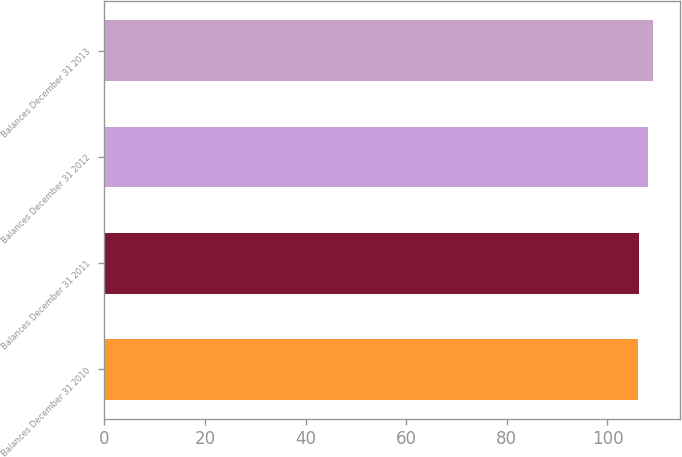<chart> <loc_0><loc_0><loc_500><loc_500><bar_chart><fcel>Balances December 31 2010<fcel>Balances December 31 2011<fcel>Balances December 31 2012<fcel>Balances December 31 2013<nl><fcel>106<fcel>106.3<fcel>108<fcel>109<nl></chart> 